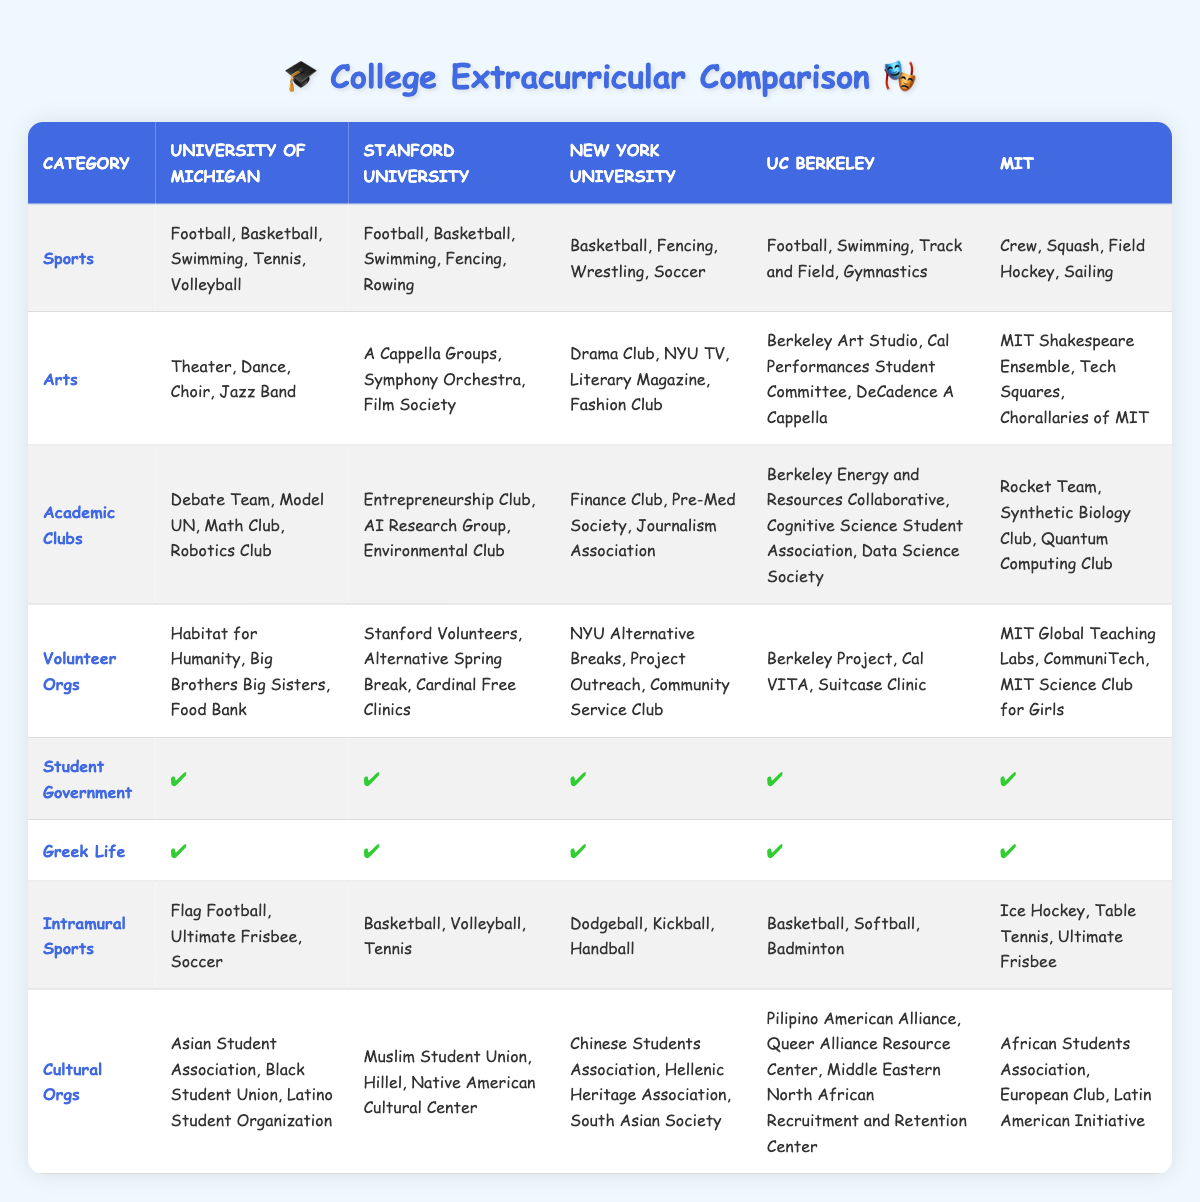What sports are offered at UC Berkeley? Looking at the "Sports" row for UC Berkeley, the listed sports are Football, Swimming, Track and Field, and Gymnastics.
Answer: Football, Swimming, Track and Field, Gymnastics Which university offers the most diverse set of arts programs? To find the university with the most diverse set of arts programs, we can compare the number of arts options for each university. University of Michigan has 4, Stanford has 3, NYU has 4, UC Berkeley has 3, and MIT has 3. Both University of Michigan and NYU offer the most with 4 options.
Answer: University of Michigan and NYU Does MIT have a student government? The "Student Government" row shows a checkmark for MIT, indicating they do have a student government.
Answer: Yes Which university has more academic clubs, Stanford or Michigan? In the "Academic Clubs" row, Stanford has 3 clubs (Entrepreneurship Club, AI Research Group, Environmental Club) while Michigan has 4 clubs (Debate Team, Model UN, Math Club, Robotics Club). Thus, Michigan has more.
Answer: Michigan How many sports are listed for New York University? The "Sports" row for New York University contains 4 options: Basketball, Fencing, Wrestling, and Soccer. By counting these options, we see there are 4 total.
Answer: 4 Which college has the least number of intramural sports? By comparing the "Intramural Sports" row, New York University has 3 sports (Dodgeball, Kickball, Handball), which is the least compared to the others.
Answer: New York University Are there any universities that do not have Greek life? The "Greek Life" row has a checkmark for every university, indicating that all of them have Greek life.
Answer: No What is the total number of volunteer organizations at Stanford and MIT combined? Stanford has 3 volunteer organizations (Stanford Volunteers, Alternative Spring Break, Cardinal Free Clinics) and MIT also has 3 (MIT Global Teaching Labs, CommuniTech, MIT Science Club for Girls). Adding these together gives 3 + 3 = 6.
Answer: 6 Which university offers rowing as a sport? In the "Sports" row, rowing is listed as one of the sports for Stanford University.
Answer: Stanford University 